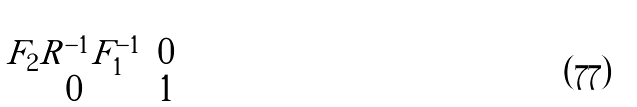Convert formula to latex. <formula><loc_0><loc_0><loc_500><loc_500>\begin{pmatrix} F _ { 2 } R ^ { - 1 } F _ { 1 } ^ { - 1 } & 0 \\ 0 & 1 \end{pmatrix}</formula> 